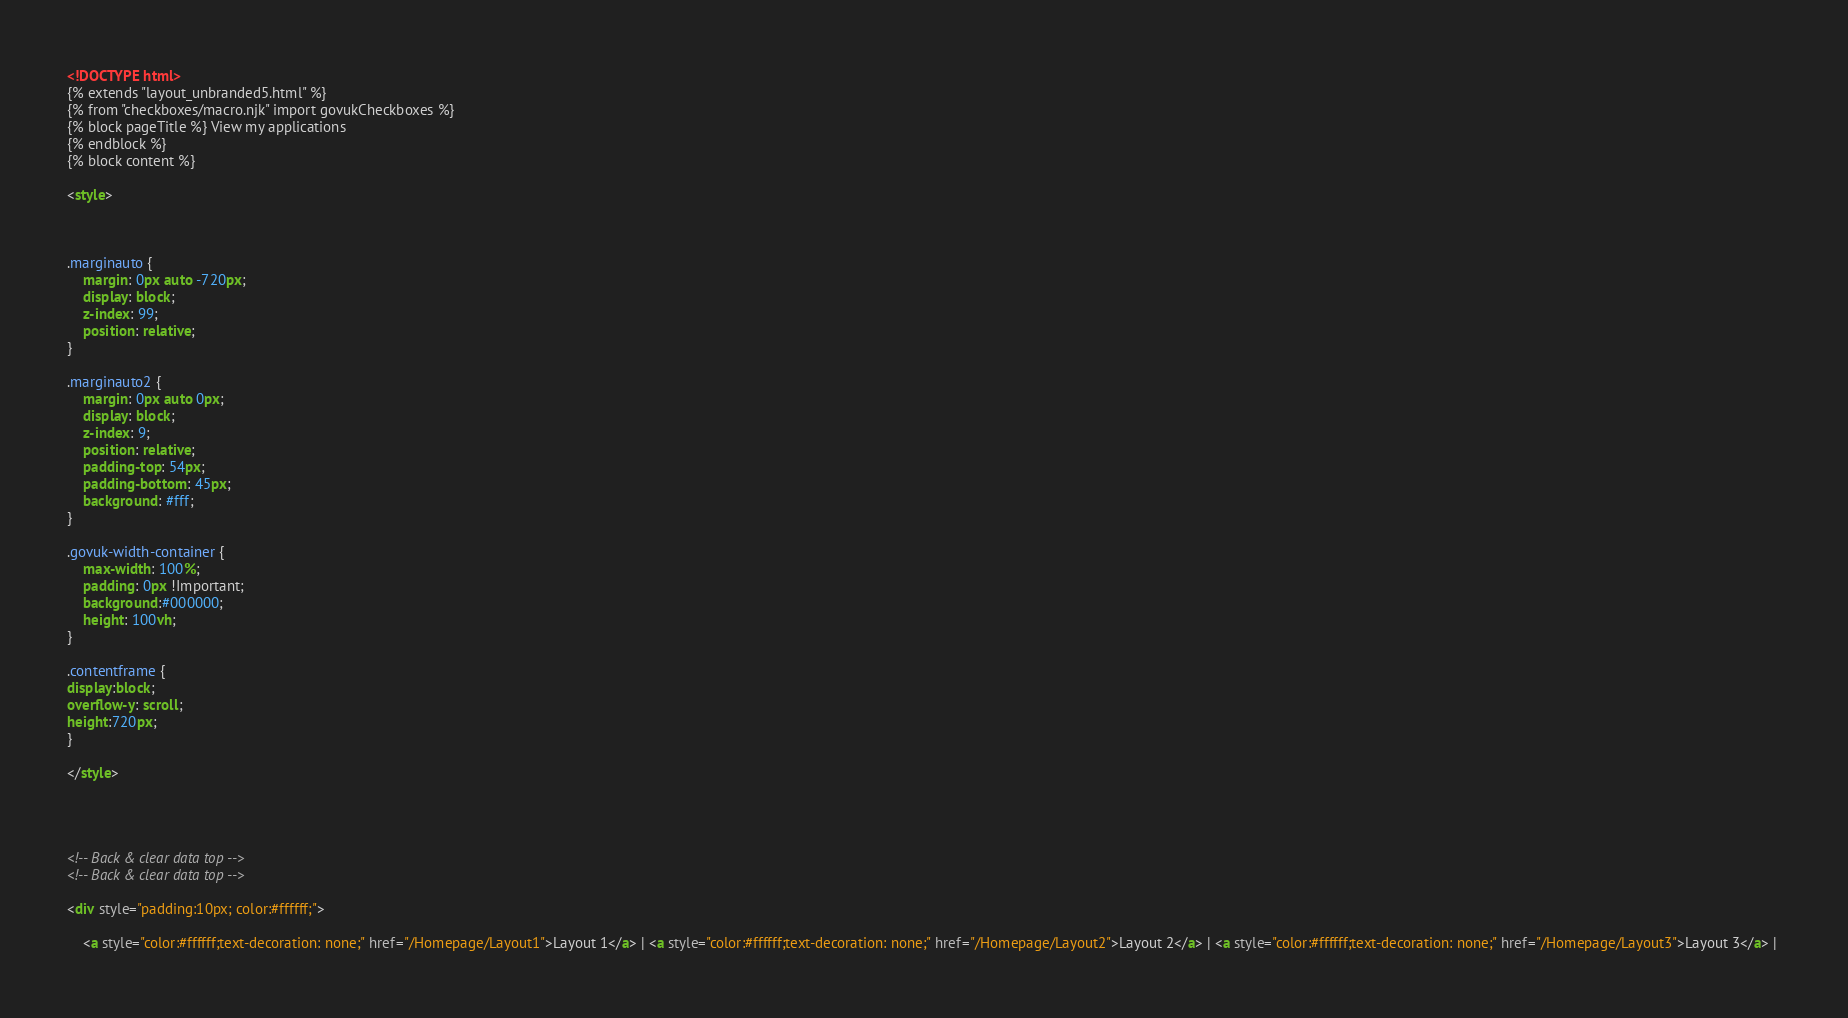Convert code to text. <code><loc_0><loc_0><loc_500><loc_500><_HTML_><!DOCTYPE html>
{% extends "layout_unbranded5.html" %}
{% from "checkboxes/macro.njk" import govukCheckboxes %}
{% block pageTitle %} View my applications
{% endblock %}
{% block content %}

<style>



.marginauto {
    margin: 0px auto -720px;
    display: block;
    z-index: 99;
    position: relative;
}

.marginauto2 {
    margin: 0px auto 0px;
    display: block;
    z-index: 9;
    position: relative;
    padding-top: 54px;
    padding-bottom: 45px;
    background: #fff;
}

.govuk-width-container {
    max-width: 100%;
    padding: 0px !Important;
    background:#000000;
    height: 100vh;
}

.contentframe {
display:block;
overflow-y: scroll;
height:720px;
}

</style>




<!-- Back & clear data top -->
<!-- Back & clear data top -->

<div style="padding:10px; color:#ffffff;">

    <a style="color:#ffffff;text-decoration: none;" href="/Homepage/Layout1">Layout 1</a> | <a style="color:#ffffff;text-decoration: none;" href="/Homepage/Layout2">Layout 2</a> | <a style="color:#ffffff;text-decoration: none;" href="/Homepage/Layout3">Layout 3</a> | 

</code> 